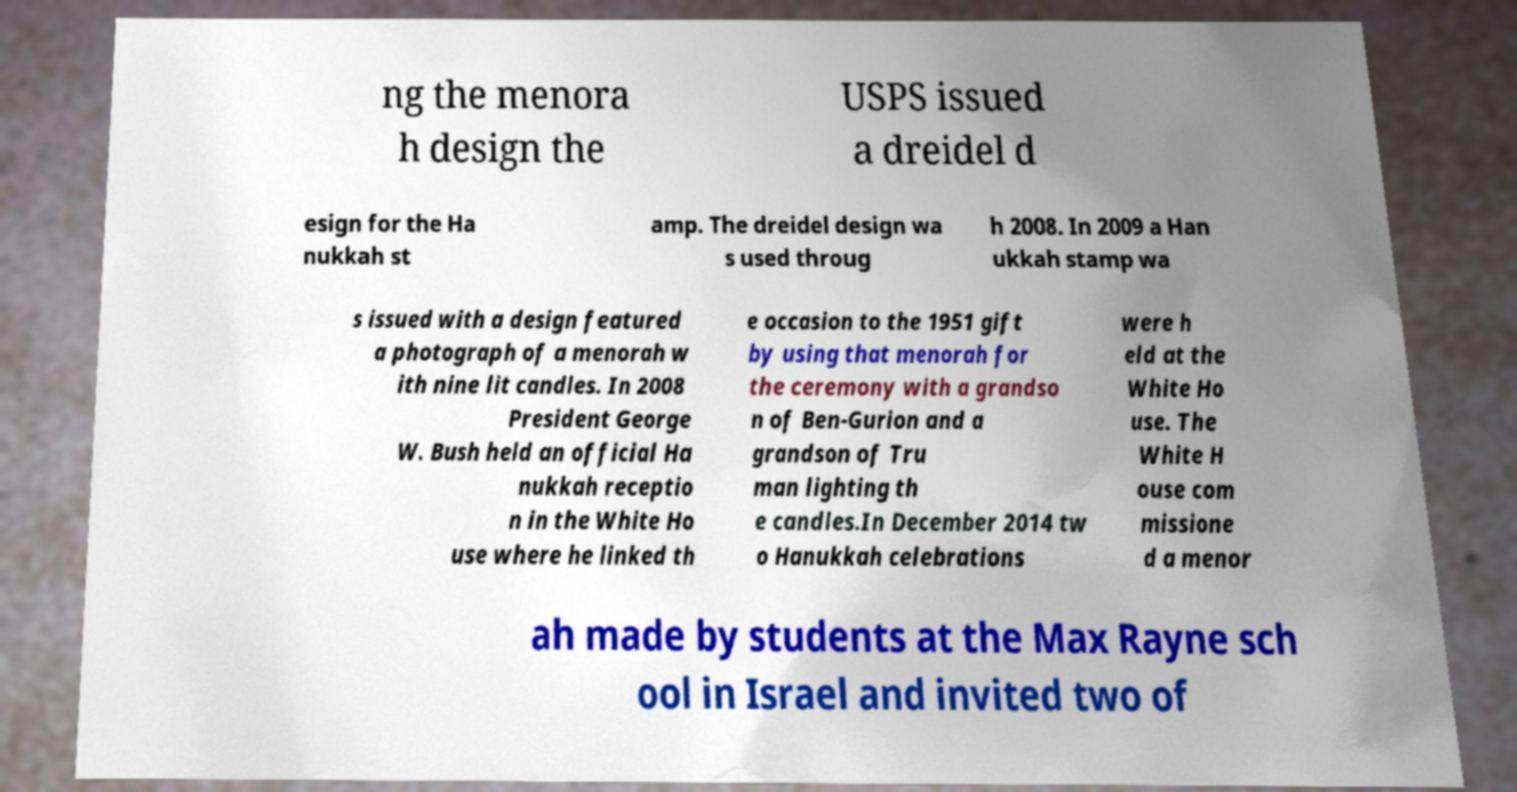Could you assist in decoding the text presented in this image and type it out clearly? ng the menora h design the USPS issued a dreidel d esign for the Ha nukkah st amp. The dreidel design wa s used throug h 2008. In 2009 a Han ukkah stamp wa s issued with a design featured a photograph of a menorah w ith nine lit candles. In 2008 President George W. Bush held an official Ha nukkah receptio n in the White Ho use where he linked th e occasion to the 1951 gift by using that menorah for the ceremony with a grandso n of Ben-Gurion and a grandson of Tru man lighting th e candles.In December 2014 tw o Hanukkah celebrations were h eld at the White Ho use. The White H ouse com missione d a menor ah made by students at the Max Rayne sch ool in Israel and invited two of 